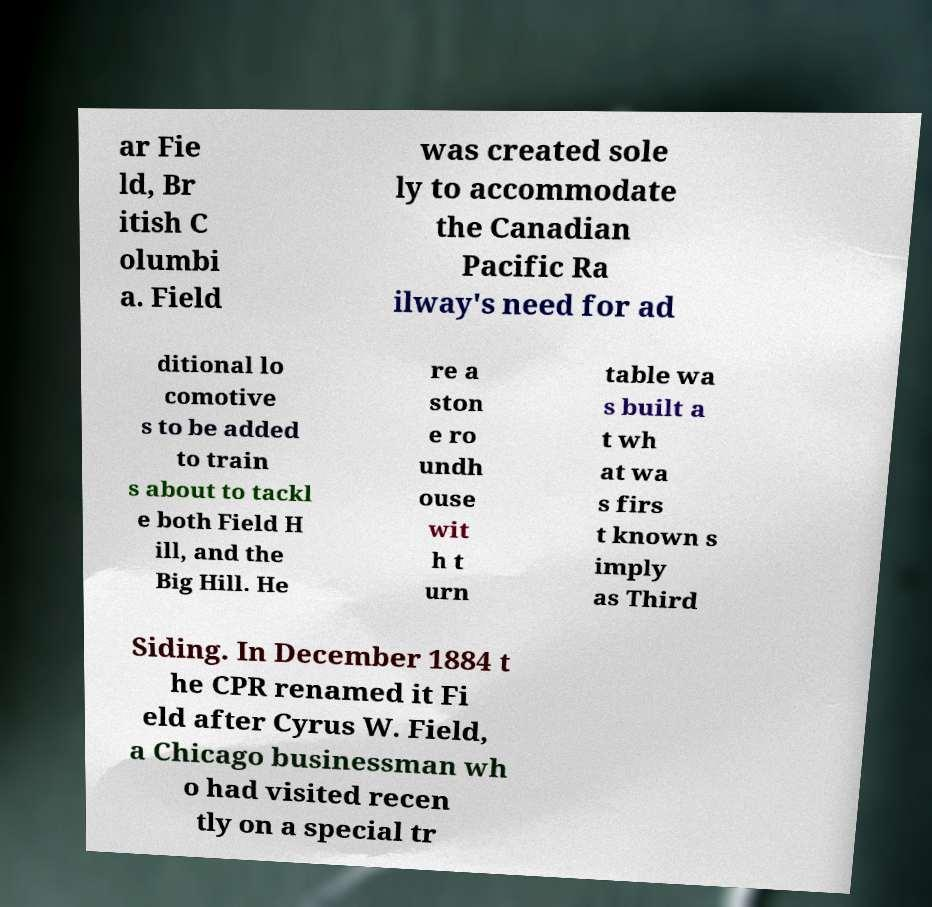I need the written content from this picture converted into text. Can you do that? ar Fie ld, Br itish C olumbi a. Field was created sole ly to accommodate the Canadian Pacific Ra ilway's need for ad ditional lo comotive s to be added to train s about to tackl e both Field H ill, and the Big Hill. He re a ston e ro undh ouse wit h t urn table wa s built a t wh at wa s firs t known s imply as Third Siding. In December 1884 t he CPR renamed it Fi eld after Cyrus W. Field, a Chicago businessman wh o had visited recen tly on a special tr 